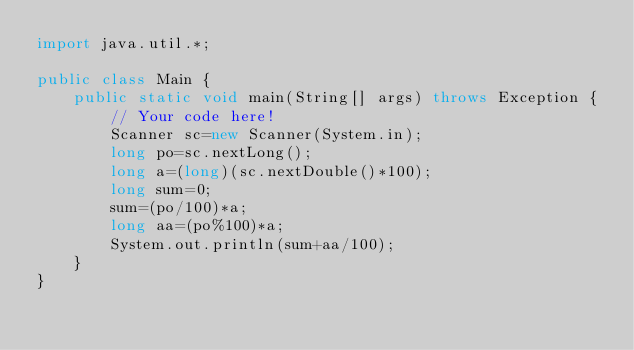Convert code to text. <code><loc_0><loc_0><loc_500><loc_500><_Java_>import java.util.*;

public class Main {
    public static void main(String[] args) throws Exception {
        // Your code here!
        Scanner sc=new Scanner(System.in);
        long po=sc.nextLong();
        long a=(long)(sc.nextDouble()*100);
        long sum=0;
        sum=(po/100)*a;
        long aa=(po%100)*a;
        System.out.println(sum+aa/100);
    }
}
</code> 